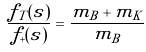Convert formula to latex. <formula><loc_0><loc_0><loc_500><loc_500>\frac { f _ { T } ( s ) } { f _ { + } ( s ) } = \frac { m _ { B } + m _ { K } } { m _ { B } }</formula> 